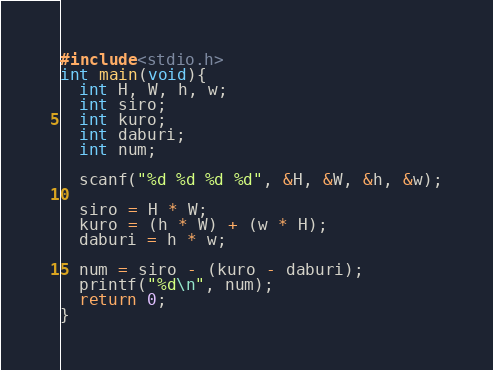<code> <loc_0><loc_0><loc_500><loc_500><_C_>#include<stdio.h>
int main(void){
  int H, W, h, w;
  int siro;
  int kuro;
  int daburi;
  int num;
  
  scanf("%d %d %d %d", &H, &W, &h, &w);
  
  siro = H * W;
  kuro = (h * W) + (w * H);
  daburi = h * w;
  
  num = siro - (kuro - daburi);
  printf("%d\n", num);
  return 0;
}

</code> 